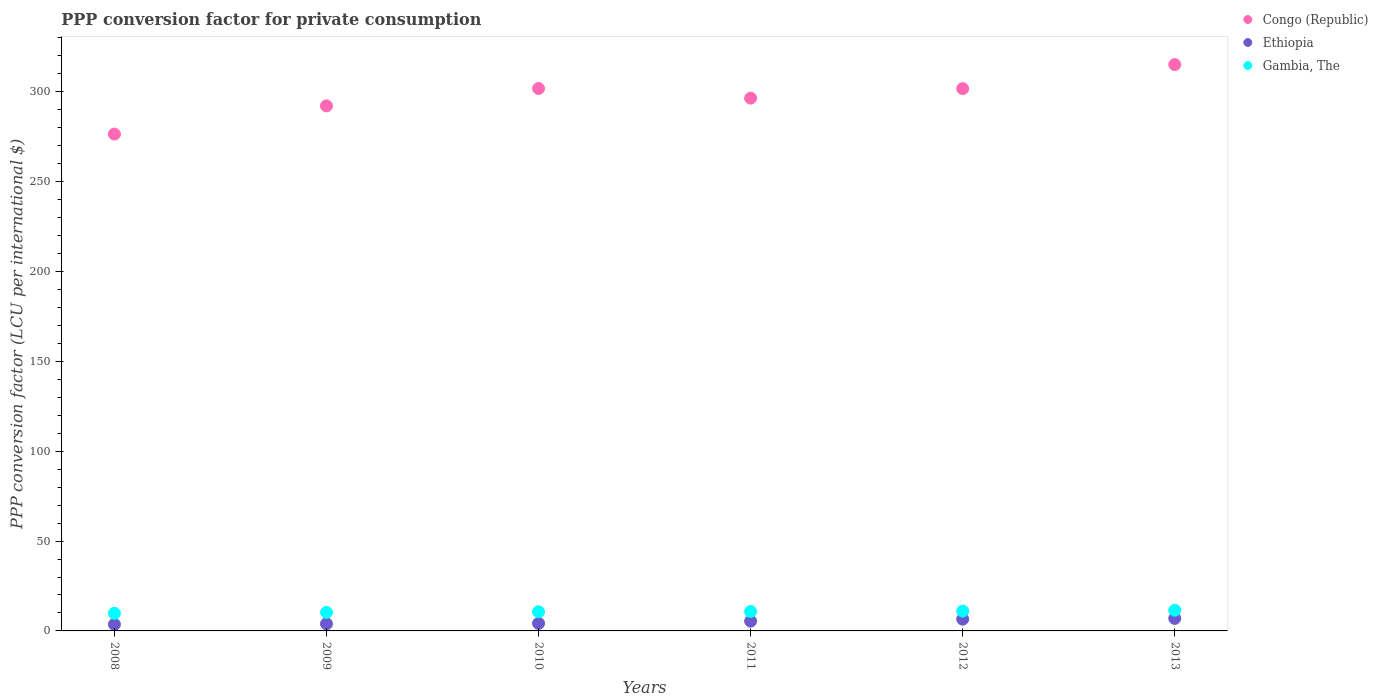Is the number of dotlines equal to the number of legend labels?
Keep it short and to the point. Yes. What is the PPP conversion factor for private consumption in Gambia, The in 2008?
Provide a short and direct response. 9.83. Across all years, what is the maximum PPP conversion factor for private consumption in Ethiopia?
Offer a terse response. 6.97. Across all years, what is the minimum PPP conversion factor for private consumption in Ethiopia?
Provide a succinct answer. 3.64. What is the total PPP conversion factor for private consumption in Ethiopia in the graph?
Your response must be concise. 30.75. What is the difference between the PPP conversion factor for private consumption in Congo (Republic) in 2009 and that in 2011?
Provide a succinct answer. -4.3. What is the difference between the PPP conversion factor for private consumption in Congo (Republic) in 2008 and the PPP conversion factor for private consumption in Ethiopia in 2012?
Make the answer very short. 269.97. What is the average PPP conversion factor for private consumption in Congo (Republic) per year?
Your answer should be compact. 297.34. In the year 2008, what is the difference between the PPP conversion factor for private consumption in Congo (Republic) and PPP conversion factor for private consumption in Gambia, The?
Offer a terse response. 266.68. In how many years, is the PPP conversion factor for private consumption in Congo (Republic) greater than 160 LCU?
Keep it short and to the point. 6. What is the ratio of the PPP conversion factor for private consumption in Congo (Republic) in 2011 to that in 2012?
Ensure brevity in your answer.  0.98. Is the PPP conversion factor for private consumption in Congo (Republic) in 2009 less than that in 2012?
Your answer should be very brief. Yes. What is the difference between the highest and the second highest PPP conversion factor for private consumption in Gambia, The?
Keep it short and to the point. 0.46. What is the difference between the highest and the lowest PPP conversion factor for private consumption in Congo (Republic)?
Make the answer very short. 38.68. In how many years, is the PPP conversion factor for private consumption in Gambia, The greater than the average PPP conversion factor for private consumption in Gambia, The taken over all years?
Give a very brief answer. 3. Is the sum of the PPP conversion factor for private consumption in Ethiopia in 2008 and 2011 greater than the maximum PPP conversion factor for private consumption in Gambia, The across all years?
Your answer should be very brief. No. How many dotlines are there?
Provide a short and direct response. 3. What is the difference between two consecutive major ticks on the Y-axis?
Offer a very short reply. 50. Does the graph contain grids?
Offer a terse response. No. Where does the legend appear in the graph?
Ensure brevity in your answer.  Top right. How many legend labels are there?
Make the answer very short. 3. What is the title of the graph?
Make the answer very short. PPP conversion factor for private consumption. Does "Sudan" appear as one of the legend labels in the graph?
Your answer should be very brief. No. What is the label or title of the Y-axis?
Keep it short and to the point. PPP conversion factor (LCU per international $). What is the PPP conversion factor (LCU per international $) of Congo (Republic) in 2008?
Provide a succinct answer. 276.51. What is the PPP conversion factor (LCU per international $) in Ethiopia in 2008?
Your answer should be very brief. 3.64. What is the PPP conversion factor (LCU per international $) of Gambia, The in 2008?
Offer a terse response. 9.83. What is the PPP conversion factor (LCU per international $) of Congo (Republic) in 2009?
Your answer should be very brief. 292.2. What is the PPP conversion factor (LCU per international $) of Ethiopia in 2009?
Provide a short and direct response. 3.96. What is the PPP conversion factor (LCU per international $) in Gambia, The in 2009?
Offer a very short reply. 10.31. What is the PPP conversion factor (LCU per international $) of Congo (Republic) in 2010?
Make the answer very short. 301.86. What is the PPP conversion factor (LCU per international $) of Ethiopia in 2010?
Your answer should be compact. 4.21. What is the PPP conversion factor (LCU per international $) in Gambia, The in 2010?
Keep it short and to the point. 10.66. What is the PPP conversion factor (LCU per international $) in Congo (Republic) in 2011?
Provide a succinct answer. 296.5. What is the PPP conversion factor (LCU per international $) in Ethiopia in 2011?
Your answer should be very brief. 5.44. What is the PPP conversion factor (LCU per international $) in Gambia, The in 2011?
Your answer should be very brief. 10.83. What is the PPP conversion factor (LCU per international $) of Congo (Republic) in 2012?
Provide a succinct answer. 301.79. What is the PPP conversion factor (LCU per international $) of Ethiopia in 2012?
Make the answer very short. 6.54. What is the PPP conversion factor (LCU per international $) of Gambia, The in 2012?
Your response must be concise. 11.06. What is the PPP conversion factor (LCU per international $) in Congo (Republic) in 2013?
Give a very brief answer. 315.19. What is the PPP conversion factor (LCU per international $) of Ethiopia in 2013?
Ensure brevity in your answer.  6.97. What is the PPP conversion factor (LCU per international $) in Gambia, The in 2013?
Offer a terse response. 11.52. Across all years, what is the maximum PPP conversion factor (LCU per international $) of Congo (Republic)?
Your response must be concise. 315.19. Across all years, what is the maximum PPP conversion factor (LCU per international $) in Ethiopia?
Your answer should be very brief. 6.97. Across all years, what is the maximum PPP conversion factor (LCU per international $) of Gambia, The?
Make the answer very short. 11.52. Across all years, what is the minimum PPP conversion factor (LCU per international $) of Congo (Republic)?
Offer a very short reply. 276.51. Across all years, what is the minimum PPP conversion factor (LCU per international $) of Ethiopia?
Provide a succinct answer. 3.64. Across all years, what is the minimum PPP conversion factor (LCU per international $) of Gambia, The?
Offer a very short reply. 9.83. What is the total PPP conversion factor (LCU per international $) in Congo (Republic) in the graph?
Offer a terse response. 1784.05. What is the total PPP conversion factor (LCU per international $) of Ethiopia in the graph?
Your answer should be compact. 30.75. What is the total PPP conversion factor (LCU per international $) of Gambia, The in the graph?
Provide a succinct answer. 64.2. What is the difference between the PPP conversion factor (LCU per international $) of Congo (Republic) in 2008 and that in 2009?
Provide a short and direct response. -15.69. What is the difference between the PPP conversion factor (LCU per international $) in Ethiopia in 2008 and that in 2009?
Offer a very short reply. -0.32. What is the difference between the PPP conversion factor (LCU per international $) of Gambia, The in 2008 and that in 2009?
Make the answer very short. -0.48. What is the difference between the PPP conversion factor (LCU per international $) of Congo (Republic) in 2008 and that in 2010?
Provide a short and direct response. -25.35. What is the difference between the PPP conversion factor (LCU per international $) in Ethiopia in 2008 and that in 2010?
Ensure brevity in your answer.  -0.57. What is the difference between the PPP conversion factor (LCU per international $) in Gambia, The in 2008 and that in 2010?
Offer a very short reply. -0.83. What is the difference between the PPP conversion factor (LCU per international $) of Congo (Republic) in 2008 and that in 2011?
Keep it short and to the point. -19.99. What is the difference between the PPP conversion factor (LCU per international $) of Ethiopia in 2008 and that in 2011?
Your response must be concise. -1.8. What is the difference between the PPP conversion factor (LCU per international $) of Gambia, The in 2008 and that in 2011?
Make the answer very short. -1. What is the difference between the PPP conversion factor (LCU per international $) in Congo (Republic) in 2008 and that in 2012?
Your answer should be compact. -25.28. What is the difference between the PPP conversion factor (LCU per international $) in Ethiopia in 2008 and that in 2012?
Offer a very short reply. -2.91. What is the difference between the PPP conversion factor (LCU per international $) in Gambia, The in 2008 and that in 2012?
Offer a very short reply. -1.23. What is the difference between the PPP conversion factor (LCU per international $) of Congo (Republic) in 2008 and that in 2013?
Give a very brief answer. -38.68. What is the difference between the PPP conversion factor (LCU per international $) in Ethiopia in 2008 and that in 2013?
Provide a succinct answer. -3.33. What is the difference between the PPP conversion factor (LCU per international $) of Gambia, The in 2008 and that in 2013?
Ensure brevity in your answer.  -1.69. What is the difference between the PPP conversion factor (LCU per international $) in Congo (Republic) in 2009 and that in 2010?
Your response must be concise. -9.66. What is the difference between the PPP conversion factor (LCU per international $) in Ethiopia in 2009 and that in 2010?
Your answer should be very brief. -0.25. What is the difference between the PPP conversion factor (LCU per international $) of Gambia, The in 2009 and that in 2010?
Your response must be concise. -0.35. What is the difference between the PPP conversion factor (LCU per international $) of Congo (Republic) in 2009 and that in 2011?
Provide a succinct answer. -4.3. What is the difference between the PPP conversion factor (LCU per international $) of Ethiopia in 2009 and that in 2011?
Your response must be concise. -1.48. What is the difference between the PPP conversion factor (LCU per international $) of Gambia, The in 2009 and that in 2011?
Offer a very short reply. -0.52. What is the difference between the PPP conversion factor (LCU per international $) in Congo (Republic) in 2009 and that in 2012?
Your response must be concise. -9.59. What is the difference between the PPP conversion factor (LCU per international $) of Ethiopia in 2009 and that in 2012?
Keep it short and to the point. -2.58. What is the difference between the PPP conversion factor (LCU per international $) in Gambia, The in 2009 and that in 2012?
Give a very brief answer. -0.75. What is the difference between the PPP conversion factor (LCU per international $) in Congo (Republic) in 2009 and that in 2013?
Offer a terse response. -22.98. What is the difference between the PPP conversion factor (LCU per international $) of Ethiopia in 2009 and that in 2013?
Provide a short and direct response. -3.01. What is the difference between the PPP conversion factor (LCU per international $) of Gambia, The in 2009 and that in 2013?
Ensure brevity in your answer.  -1.21. What is the difference between the PPP conversion factor (LCU per international $) in Congo (Republic) in 2010 and that in 2011?
Your answer should be compact. 5.36. What is the difference between the PPP conversion factor (LCU per international $) of Ethiopia in 2010 and that in 2011?
Your answer should be compact. -1.23. What is the difference between the PPP conversion factor (LCU per international $) of Gambia, The in 2010 and that in 2011?
Make the answer very short. -0.17. What is the difference between the PPP conversion factor (LCU per international $) in Congo (Republic) in 2010 and that in 2012?
Provide a succinct answer. 0.07. What is the difference between the PPP conversion factor (LCU per international $) of Ethiopia in 2010 and that in 2012?
Give a very brief answer. -2.33. What is the difference between the PPP conversion factor (LCU per international $) of Gambia, The in 2010 and that in 2012?
Give a very brief answer. -0.4. What is the difference between the PPP conversion factor (LCU per international $) in Congo (Republic) in 2010 and that in 2013?
Keep it short and to the point. -13.33. What is the difference between the PPP conversion factor (LCU per international $) of Ethiopia in 2010 and that in 2013?
Ensure brevity in your answer.  -2.76. What is the difference between the PPP conversion factor (LCU per international $) of Gambia, The in 2010 and that in 2013?
Your answer should be compact. -0.86. What is the difference between the PPP conversion factor (LCU per international $) in Congo (Republic) in 2011 and that in 2012?
Your response must be concise. -5.29. What is the difference between the PPP conversion factor (LCU per international $) in Ethiopia in 2011 and that in 2012?
Your answer should be very brief. -1.1. What is the difference between the PPP conversion factor (LCU per international $) of Gambia, The in 2011 and that in 2012?
Offer a terse response. -0.23. What is the difference between the PPP conversion factor (LCU per international $) in Congo (Republic) in 2011 and that in 2013?
Offer a very short reply. -18.69. What is the difference between the PPP conversion factor (LCU per international $) of Ethiopia in 2011 and that in 2013?
Provide a short and direct response. -1.53. What is the difference between the PPP conversion factor (LCU per international $) of Gambia, The in 2011 and that in 2013?
Offer a terse response. -0.69. What is the difference between the PPP conversion factor (LCU per international $) in Congo (Republic) in 2012 and that in 2013?
Your answer should be compact. -13.4. What is the difference between the PPP conversion factor (LCU per international $) of Ethiopia in 2012 and that in 2013?
Keep it short and to the point. -0.43. What is the difference between the PPP conversion factor (LCU per international $) in Gambia, The in 2012 and that in 2013?
Offer a very short reply. -0.46. What is the difference between the PPP conversion factor (LCU per international $) in Congo (Republic) in 2008 and the PPP conversion factor (LCU per international $) in Ethiopia in 2009?
Offer a very short reply. 272.55. What is the difference between the PPP conversion factor (LCU per international $) of Congo (Republic) in 2008 and the PPP conversion factor (LCU per international $) of Gambia, The in 2009?
Offer a terse response. 266.2. What is the difference between the PPP conversion factor (LCU per international $) of Ethiopia in 2008 and the PPP conversion factor (LCU per international $) of Gambia, The in 2009?
Offer a terse response. -6.68. What is the difference between the PPP conversion factor (LCU per international $) in Congo (Republic) in 2008 and the PPP conversion factor (LCU per international $) in Ethiopia in 2010?
Your answer should be very brief. 272.3. What is the difference between the PPP conversion factor (LCU per international $) in Congo (Republic) in 2008 and the PPP conversion factor (LCU per international $) in Gambia, The in 2010?
Your response must be concise. 265.85. What is the difference between the PPP conversion factor (LCU per international $) in Ethiopia in 2008 and the PPP conversion factor (LCU per international $) in Gambia, The in 2010?
Ensure brevity in your answer.  -7.02. What is the difference between the PPP conversion factor (LCU per international $) of Congo (Republic) in 2008 and the PPP conversion factor (LCU per international $) of Ethiopia in 2011?
Your response must be concise. 271.07. What is the difference between the PPP conversion factor (LCU per international $) in Congo (Republic) in 2008 and the PPP conversion factor (LCU per international $) in Gambia, The in 2011?
Your response must be concise. 265.68. What is the difference between the PPP conversion factor (LCU per international $) of Ethiopia in 2008 and the PPP conversion factor (LCU per international $) of Gambia, The in 2011?
Keep it short and to the point. -7.19. What is the difference between the PPP conversion factor (LCU per international $) of Congo (Republic) in 2008 and the PPP conversion factor (LCU per international $) of Ethiopia in 2012?
Ensure brevity in your answer.  269.97. What is the difference between the PPP conversion factor (LCU per international $) in Congo (Republic) in 2008 and the PPP conversion factor (LCU per international $) in Gambia, The in 2012?
Offer a terse response. 265.45. What is the difference between the PPP conversion factor (LCU per international $) in Ethiopia in 2008 and the PPP conversion factor (LCU per international $) in Gambia, The in 2012?
Your answer should be very brief. -7.42. What is the difference between the PPP conversion factor (LCU per international $) in Congo (Republic) in 2008 and the PPP conversion factor (LCU per international $) in Ethiopia in 2013?
Give a very brief answer. 269.54. What is the difference between the PPP conversion factor (LCU per international $) of Congo (Republic) in 2008 and the PPP conversion factor (LCU per international $) of Gambia, The in 2013?
Ensure brevity in your answer.  264.99. What is the difference between the PPP conversion factor (LCU per international $) in Ethiopia in 2008 and the PPP conversion factor (LCU per international $) in Gambia, The in 2013?
Make the answer very short. -7.88. What is the difference between the PPP conversion factor (LCU per international $) in Congo (Republic) in 2009 and the PPP conversion factor (LCU per international $) in Ethiopia in 2010?
Keep it short and to the point. 287.99. What is the difference between the PPP conversion factor (LCU per international $) in Congo (Republic) in 2009 and the PPP conversion factor (LCU per international $) in Gambia, The in 2010?
Offer a terse response. 281.55. What is the difference between the PPP conversion factor (LCU per international $) in Ethiopia in 2009 and the PPP conversion factor (LCU per international $) in Gambia, The in 2010?
Provide a short and direct response. -6.7. What is the difference between the PPP conversion factor (LCU per international $) in Congo (Republic) in 2009 and the PPP conversion factor (LCU per international $) in Ethiopia in 2011?
Provide a short and direct response. 286.76. What is the difference between the PPP conversion factor (LCU per international $) of Congo (Republic) in 2009 and the PPP conversion factor (LCU per international $) of Gambia, The in 2011?
Offer a terse response. 281.38. What is the difference between the PPP conversion factor (LCU per international $) of Ethiopia in 2009 and the PPP conversion factor (LCU per international $) of Gambia, The in 2011?
Keep it short and to the point. -6.87. What is the difference between the PPP conversion factor (LCU per international $) in Congo (Republic) in 2009 and the PPP conversion factor (LCU per international $) in Ethiopia in 2012?
Give a very brief answer. 285.66. What is the difference between the PPP conversion factor (LCU per international $) in Congo (Republic) in 2009 and the PPP conversion factor (LCU per international $) in Gambia, The in 2012?
Your response must be concise. 281.14. What is the difference between the PPP conversion factor (LCU per international $) of Ethiopia in 2009 and the PPP conversion factor (LCU per international $) of Gambia, The in 2012?
Your answer should be compact. -7.1. What is the difference between the PPP conversion factor (LCU per international $) in Congo (Republic) in 2009 and the PPP conversion factor (LCU per international $) in Ethiopia in 2013?
Offer a terse response. 285.24. What is the difference between the PPP conversion factor (LCU per international $) in Congo (Republic) in 2009 and the PPP conversion factor (LCU per international $) in Gambia, The in 2013?
Your response must be concise. 280.68. What is the difference between the PPP conversion factor (LCU per international $) of Ethiopia in 2009 and the PPP conversion factor (LCU per international $) of Gambia, The in 2013?
Give a very brief answer. -7.56. What is the difference between the PPP conversion factor (LCU per international $) in Congo (Republic) in 2010 and the PPP conversion factor (LCU per international $) in Ethiopia in 2011?
Offer a very short reply. 296.42. What is the difference between the PPP conversion factor (LCU per international $) of Congo (Republic) in 2010 and the PPP conversion factor (LCU per international $) of Gambia, The in 2011?
Offer a terse response. 291.03. What is the difference between the PPP conversion factor (LCU per international $) of Ethiopia in 2010 and the PPP conversion factor (LCU per international $) of Gambia, The in 2011?
Keep it short and to the point. -6.62. What is the difference between the PPP conversion factor (LCU per international $) of Congo (Republic) in 2010 and the PPP conversion factor (LCU per international $) of Ethiopia in 2012?
Offer a very short reply. 295.32. What is the difference between the PPP conversion factor (LCU per international $) of Congo (Republic) in 2010 and the PPP conversion factor (LCU per international $) of Gambia, The in 2012?
Your response must be concise. 290.8. What is the difference between the PPP conversion factor (LCU per international $) of Ethiopia in 2010 and the PPP conversion factor (LCU per international $) of Gambia, The in 2012?
Your answer should be very brief. -6.85. What is the difference between the PPP conversion factor (LCU per international $) in Congo (Republic) in 2010 and the PPP conversion factor (LCU per international $) in Ethiopia in 2013?
Keep it short and to the point. 294.89. What is the difference between the PPP conversion factor (LCU per international $) of Congo (Republic) in 2010 and the PPP conversion factor (LCU per international $) of Gambia, The in 2013?
Offer a very short reply. 290.34. What is the difference between the PPP conversion factor (LCU per international $) in Ethiopia in 2010 and the PPP conversion factor (LCU per international $) in Gambia, The in 2013?
Provide a short and direct response. -7.31. What is the difference between the PPP conversion factor (LCU per international $) of Congo (Republic) in 2011 and the PPP conversion factor (LCU per international $) of Ethiopia in 2012?
Your answer should be compact. 289.96. What is the difference between the PPP conversion factor (LCU per international $) in Congo (Republic) in 2011 and the PPP conversion factor (LCU per international $) in Gambia, The in 2012?
Provide a succinct answer. 285.44. What is the difference between the PPP conversion factor (LCU per international $) of Ethiopia in 2011 and the PPP conversion factor (LCU per international $) of Gambia, The in 2012?
Make the answer very short. -5.62. What is the difference between the PPP conversion factor (LCU per international $) of Congo (Republic) in 2011 and the PPP conversion factor (LCU per international $) of Ethiopia in 2013?
Your answer should be very brief. 289.53. What is the difference between the PPP conversion factor (LCU per international $) of Congo (Republic) in 2011 and the PPP conversion factor (LCU per international $) of Gambia, The in 2013?
Provide a succinct answer. 284.98. What is the difference between the PPP conversion factor (LCU per international $) of Ethiopia in 2011 and the PPP conversion factor (LCU per international $) of Gambia, The in 2013?
Your answer should be very brief. -6.08. What is the difference between the PPP conversion factor (LCU per international $) in Congo (Republic) in 2012 and the PPP conversion factor (LCU per international $) in Ethiopia in 2013?
Make the answer very short. 294.82. What is the difference between the PPP conversion factor (LCU per international $) in Congo (Republic) in 2012 and the PPP conversion factor (LCU per international $) in Gambia, The in 2013?
Your answer should be very brief. 290.27. What is the difference between the PPP conversion factor (LCU per international $) in Ethiopia in 2012 and the PPP conversion factor (LCU per international $) in Gambia, The in 2013?
Make the answer very short. -4.98. What is the average PPP conversion factor (LCU per international $) in Congo (Republic) per year?
Your answer should be very brief. 297.34. What is the average PPP conversion factor (LCU per international $) in Ethiopia per year?
Your answer should be very brief. 5.13. What is the average PPP conversion factor (LCU per international $) in Gambia, The per year?
Provide a succinct answer. 10.7. In the year 2008, what is the difference between the PPP conversion factor (LCU per international $) of Congo (Republic) and PPP conversion factor (LCU per international $) of Ethiopia?
Your answer should be compact. 272.87. In the year 2008, what is the difference between the PPP conversion factor (LCU per international $) of Congo (Republic) and PPP conversion factor (LCU per international $) of Gambia, The?
Give a very brief answer. 266.68. In the year 2008, what is the difference between the PPP conversion factor (LCU per international $) of Ethiopia and PPP conversion factor (LCU per international $) of Gambia, The?
Offer a terse response. -6.19. In the year 2009, what is the difference between the PPP conversion factor (LCU per international $) in Congo (Republic) and PPP conversion factor (LCU per international $) in Ethiopia?
Your response must be concise. 288.25. In the year 2009, what is the difference between the PPP conversion factor (LCU per international $) in Congo (Republic) and PPP conversion factor (LCU per international $) in Gambia, The?
Make the answer very short. 281.89. In the year 2009, what is the difference between the PPP conversion factor (LCU per international $) of Ethiopia and PPP conversion factor (LCU per international $) of Gambia, The?
Make the answer very short. -6.35. In the year 2010, what is the difference between the PPP conversion factor (LCU per international $) in Congo (Republic) and PPP conversion factor (LCU per international $) in Ethiopia?
Offer a terse response. 297.65. In the year 2010, what is the difference between the PPP conversion factor (LCU per international $) in Congo (Republic) and PPP conversion factor (LCU per international $) in Gambia, The?
Provide a succinct answer. 291.2. In the year 2010, what is the difference between the PPP conversion factor (LCU per international $) in Ethiopia and PPP conversion factor (LCU per international $) in Gambia, The?
Offer a terse response. -6.45. In the year 2011, what is the difference between the PPP conversion factor (LCU per international $) in Congo (Republic) and PPP conversion factor (LCU per international $) in Ethiopia?
Offer a very short reply. 291.06. In the year 2011, what is the difference between the PPP conversion factor (LCU per international $) of Congo (Republic) and PPP conversion factor (LCU per international $) of Gambia, The?
Offer a terse response. 285.67. In the year 2011, what is the difference between the PPP conversion factor (LCU per international $) of Ethiopia and PPP conversion factor (LCU per international $) of Gambia, The?
Provide a succinct answer. -5.39. In the year 2012, what is the difference between the PPP conversion factor (LCU per international $) of Congo (Republic) and PPP conversion factor (LCU per international $) of Ethiopia?
Offer a terse response. 295.25. In the year 2012, what is the difference between the PPP conversion factor (LCU per international $) in Congo (Republic) and PPP conversion factor (LCU per international $) in Gambia, The?
Provide a succinct answer. 290.73. In the year 2012, what is the difference between the PPP conversion factor (LCU per international $) in Ethiopia and PPP conversion factor (LCU per international $) in Gambia, The?
Offer a very short reply. -4.52. In the year 2013, what is the difference between the PPP conversion factor (LCU per international $) in Congo (Republic) and PPP conversion factor (LCU per international $) in Ethiopia?
Keep it short and to the point. 308.22. In the year 2013, what is the difference between the PPP conversion factor (LCU per international $) of Congo (Republic) and PPP conversion factor (LCU per international $) of Gambia, The?
Offer a very short reply. 303.67. In the year 2013, what is the difference between the PPP conversion factor (LCU per international $) in Ethiopia and PPP conversion factor (LCU per international $) in Gambia, The?
Keep it short and to the point. -4.55. What is the ratio of the PPP conversion factor (LCU per international $) in Congo (Republic) in 2008 to that in 2009?
Provide a short and direct response. 0.95. What is the ratio of the PPP conversion factor (LCU per international $) in Ethiopia in 2008 to that in 2009?
Ensure brevity in your answer.  0.92. What is the ratio of the PPP conversion factor (LCU per international $) in Gambia, The in 2008 to that in 2009?
Ensure brevity in your answer.  0.95. What is the ratio of the PPP conversion factor (LCU per international $) of Congo (Republic) in 2008 to that in 2010?
Provide a short and direct response. 0.92. What is the ratio of the PPP conversion factor (LCU per international $) in Ethiopia in 2008 to that in 2010?
Ensure brevity in your answer.  0.86. What is the ratio of the PPP conversion factor (LCU per international $) in Gambia, The in 2008 to that in 2010?
Offer a terse response. 0.92. What is the ratio of the PPP conversion factor (LCU per international $) in Congo (Republic) in 2008 to that in 2011?
Provide a succinct answer. 0.93. What is the ratio of the PPP conversion factor (LCU per international $) of Ethiopia in 2008 to that in 2011?
Keep it short and to the point. 0.67. What is the ratio of the PPP conversion factor (LCU per international $) in Gambia, The in 2008 to that in 2011?
Provide a succinct answer. 0.91. What is the ratio of the PPP conversion factor (LCU per international $) of Congo (Republic) in 2008 to that in 2012?
Your response must be concise. 0.92. What is the ratio of the PPP conversion factor (LCU per international $) of Ethiopia in 2008 to that in 2012?
Give a very brief answer. 0.56. What is the ratio of the PPP conversion factor (LCU per international $) of Gambia, The in 2008 to that in 2012?
Ensure brevity in your answer.  0.89. What is the ratio of the PPP conversion factor (LCU per international $) of Congo (Republic) in 2008 to that in 2013?
Give a very brief answer. 0.88. What is the ratio of the PPP conversion factor (LCU per international $) of Ethiopia in 2008 to that in 2013?
Your answer should be very brief. 0.52. What is the ratio of the PPP conversion factor (LCU per international $) of Gambia, The in 2008 to that in 2013?
Provide a short and direct response. 0.85. What is the ratio of the PPP conversion factor (LCU per international $) of Congo (Republic) in 2009 to that in 2010?
Provide a short and direct response. 0.97. What is the ratio of the PPP conversion factor (LCU per international $) of Ethiopia in 2009 to that in 2010?
Provide a short and direct response. 0.94. What is the ratio of the PPP conversion factor (LCU per international $) of Gambia, The in 2009 to that in 2010?
Offer a terse response. 0.97. What is the ratio of the PPP conversion factor (LCU per international $) in Congo (Republic) in 2009 to that in 2011?
Ensure brevity in your answer.  0.99. What is the ratio of the PPP conversion factor (LCU per international $) in Ethiopia in 2009 to that in 2011?
Offer a terse response. 0.73. What is the ratio of the PPP conversion factor (LCU per international $) of Congo (Republic) in 2009 to that in 2012?
Provide a short and direct response. 0.97. What is the ratio of the PPP conversion factor (LCU per international $) of Ethiopia in 2009 to that in 2012?
Make the answer very short. 0.61. What is the ratio of the PPP conversion factor (LCU per international $) of Gambia, The in 2009 to that in 2012?
Provide a short and direct response. 0.93. What is the ratio of the PPP conversion factor (LCU per international $) of Congo (Republic) in 2009 to that in 2013?
Your answer should be compact. 0.93. What is the ratio of the PPP conversion factor (LCU per international $) in Ethiopia in 2009 to that in 2013?
Your answer should be compact. 0.57. What is the ratio of the PPP conversion factor (LCU per international $) in Gambia, The in 2009 to that in 2013?
Provide a succinct answer. 0.9. What is the ratio of the PPP conversion factor (LCU per international $) in Congo (Republic) in 2010 to that in 2011?
Ensure brevity in your answer.  1.02. What is the ratio of the PPP conversion factor (LCU per international $) in Ethiopia in 2010 to that in 2011?
Provide a short and direct response. 0.77. What is the ratio of the PPP conversion factor (LCU per international $) in Gambia, The in 2010 to that in 2011?
Offer a terse response. 0.98. What is the ratio of the PPP conversion factor (LCU per international $) in Ethiopia in 2010 to that in 2012?
Your answer should be compact. 0.64. What is the ratio of the PPP conversion factor (LCU per international $) in Gambia, The in 2010 to that in 2012?
Offer a terse response. 0.96. What is the ratio of the PPP conversion factor (LCU per international $) of Congo (Republic) in 2010 to that in 2013?
Provide a short and direct response. 0.96. What is the ratio of the PPP conversion factor (LCU per international $) in Ethiopia in 2010 to that in 2013?
Offer a terse response. 0.6. What is the ratio of the PPP conversion factor (LCU per international $) in Gambia, The in 2010 to that in 2013?
Make the answer very short. 0.93. What is the ratio of the PPP conversion factor (LCU per international $) in Congo (Republic) in 2011 to that in 2012?
Provide a succinct answer. 0.98. What is the ratio of the PPP conversion factor (LCU per international $) in Ethiopia in 2011 to that in 2012?
Offer a very short reply. 0.83. What is the ratio of the PPP conversion factor (LCU per international $) in Congo (Republic) in 2011 to that in 2013?
Your answer should be compact. 0.94. What is the ratio of the PPP conversion factor (LCU per international $) of Ethiopia in 2011 to that in 2013?
Your answer should be compact. 0.78. What is the ratio of the PPP conversion factor (LCU per international $) in Gambia, The in 2011 to that in 2013?
Your answer should be compact. 0.94. What is the ratio of the PPP conversion factor (LCU per international $) of Congo (Republic) in 2012 to that in 2013?
Keep it short and to the point. 0.96. What is the ratio of the PPP conversion factor (LCU per international $) in Ethiopia in 2012 to that in 2013?
Offer a terse response. 0.94. What is the ratio of the PPP conversion factor (LCU per international $) in Gambia, The in 2012 to that in 2013?
Offer a very short reply. 0.96. What is the difference between the highest and the second highest PPP conversion factor (LCU per international $) in Congo (Republic)?
Ensure brevity in your answer.  13.33. What is the difference between the highest and the second highest PPP conversion factor (LCU per international $) of Ethiopia?
Make the answer very short. 0.43. What is the difference between the highest and the second highest PPP conversion factor (LCU per international $) in Gambia, The?
Keep it short and to the point. 0.46. What is the difference between the highest and the lowest PPP conversion factor (LCU per international $) in Congo (Republic)?
Your answer should be very brief. 38.68. What is the difference between the highest and the lowest PPP conversion factor (LCU per international $) in Ethiopia?
Your response must be concise. 3.33. What is the difference between the highest and the lowest PPP conversion factor (LCU per international $) of Gambia, The?
Make the answer very short. 1.69. 